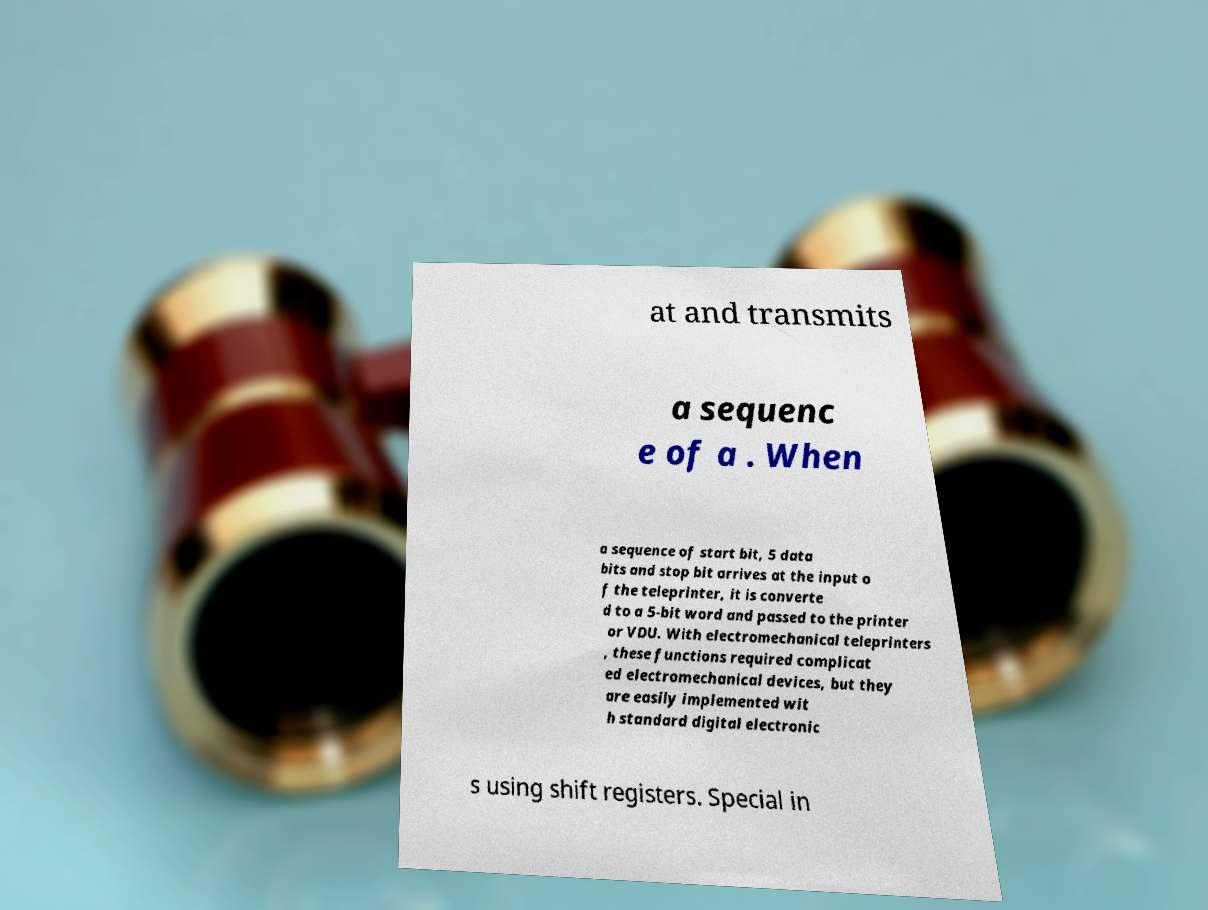Please read and relay the text visible in this image. What does it say? at and transmits a sequenc e of a . When a sequence of start bit, 5 data bits and stop bit arrives at the input o f the teleprinter, it is converte d to a 5-bit word and passed to the printer or VDU. With electromechanical teleprinters , these functions required complicat ed electromechanical devices, but they are easily implemented wit h standard digital electronic s using shift registers. Special in 